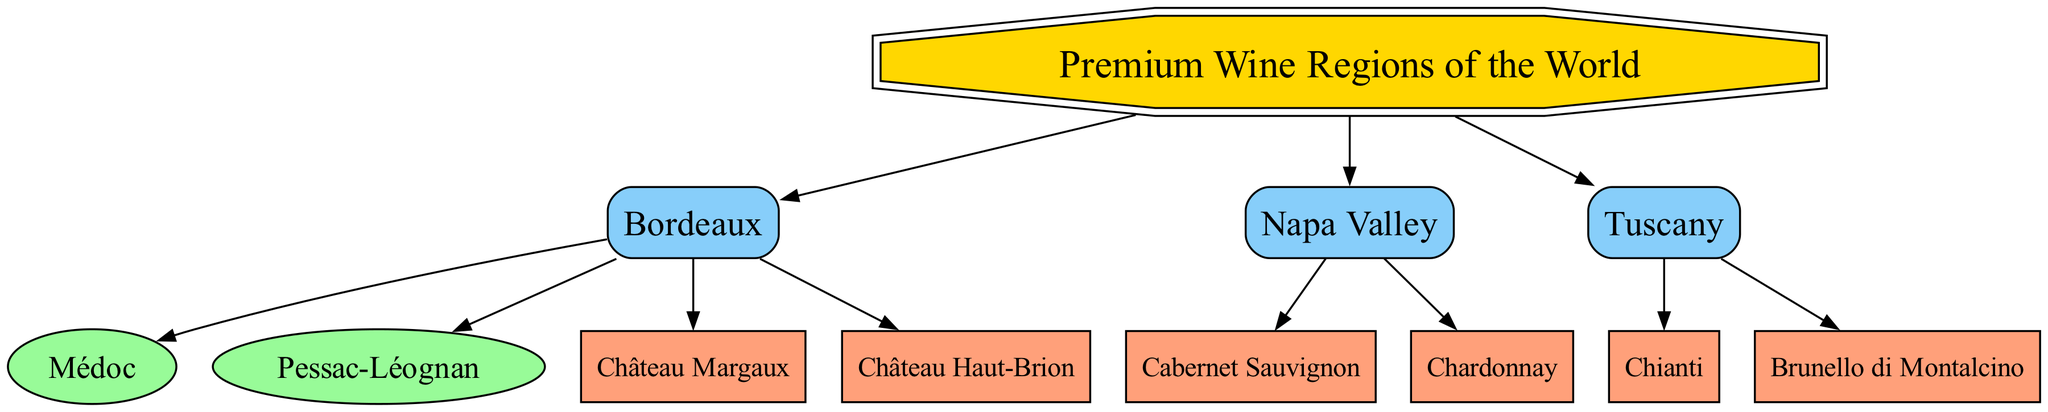What are the premium wine regions highlighted in this diagram? The diagram identifies three premium wine regions: Bordeaux, Napa Valley, and Tuscany. Each region is listed under the main topic "Premium Wine Regions of the World".
Answer: Bordeaux, Napa Valley, Tuscany How many wines are associated with Napa Valley? In the diagram, Napa Valley is connected to two wines, which are Cabernet Sauvignon and Chardonnay. This information can be obtained by counting the edges connecting Napa Valley to its associated wines.
Answer: 2 Which Bordeaux sub-region is mentioned in the diagram? The diagram shows two sub-regions of Bordeaux: Médoc and Pessac-Léognan. The question specifically asks for any mentioned sub-region; either of these would be a correct answer.
Answer: Médoc, Pessac-Léognan What wine is a signature of Tuscany? The diagram indicates that Chianti and Brunello di Montalcino are both signature wines of Tuscany. By identifying the wines connected to the Tuscany region, you can quickly ascertain their names.
Answer: Chianti, Brunello di Montalcino Which wine comes from Bordeaux and is known as Château Margaux? In the diagram, Château Margaux is listed as a wine produced in Bordeaux. To answer this question, one simply needs to refer to the wines linked directly to the Bordeaux region.
Answer: Château Margaux What is the total number of edges in the diagram? The diagram counts the connections (edges) made between nodes. After examining the diagram, it can be determined that there are 10 edges in total, which connect various regions to their wines and sub-regions.
Answer: 10 Which wine is associated with Napa Valley and is a varietal famous for its bold flavor? The bold-flavored wine connected to Napa Valley in the diagram is Cabernet Sauvignon. This can be found by looking at the wines listed under the Napa Valley node.
Answer: Cabernet Sauvignon What distinguishes the wine regions in the diagram based on the types of wines produced? The wine regions in the diagram differ by the types of wines produced, with Napa Valley primarily known for Cabernet Sauvignon and Chardonnay, Tuscany for Chianti and Brunello di Montalcino, and Bordeaux for wines like Château Margaux and Château Haut-Brion. This requires synthesizing information from various parts of the diagram.
Answer: Varietals 